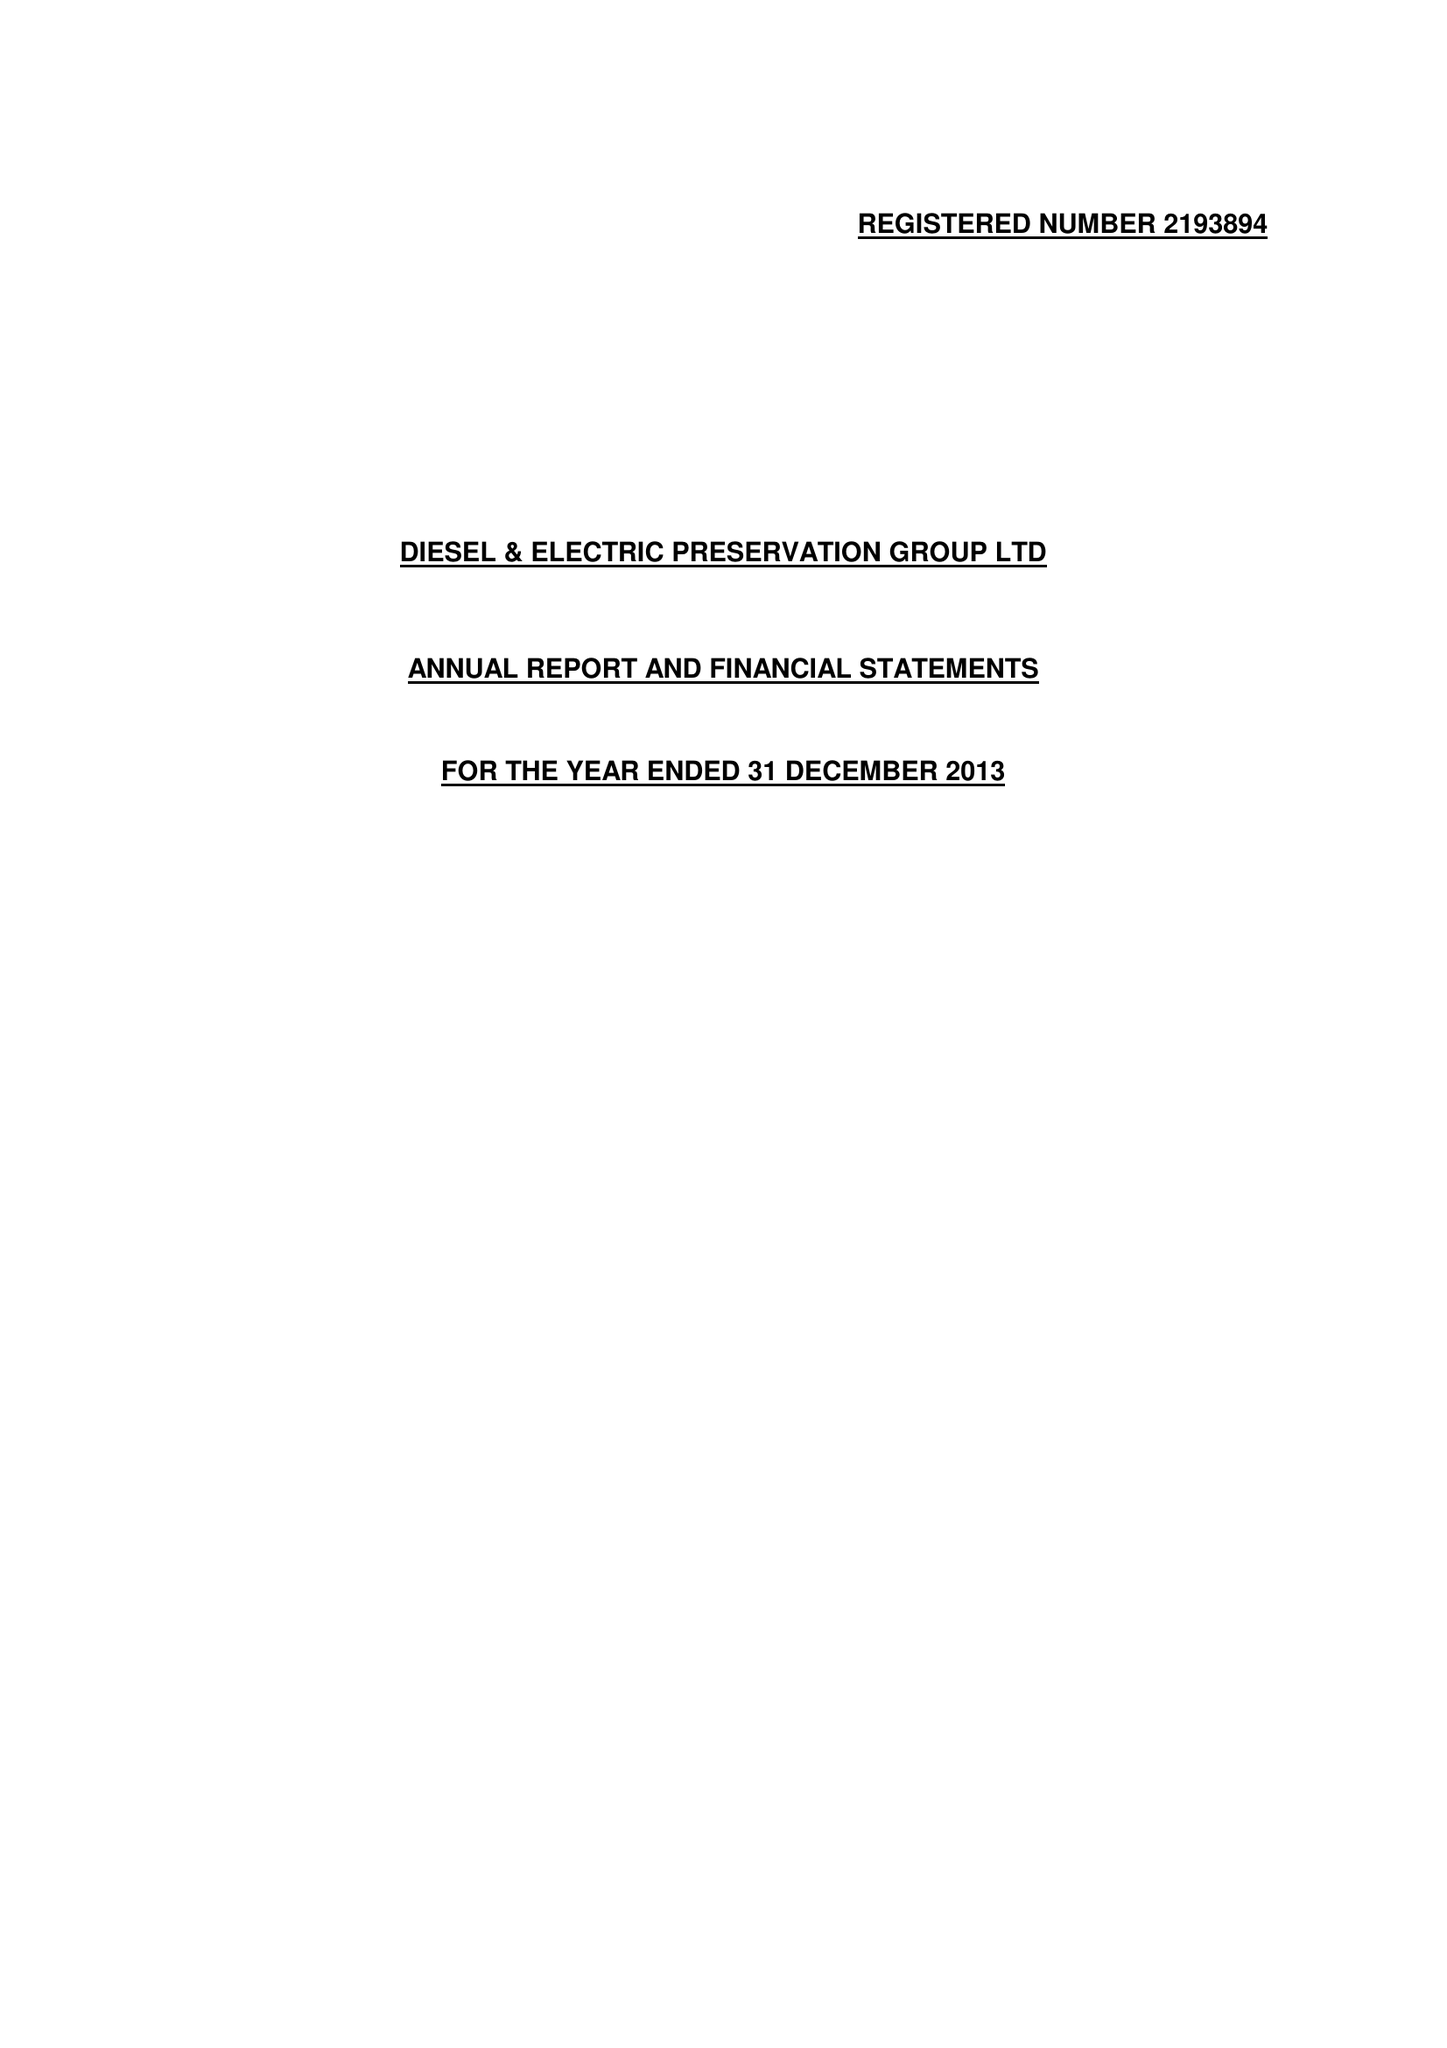What is the value for the address__postcode?
Answer the question using a single word or phrase. TA4 4RQ 